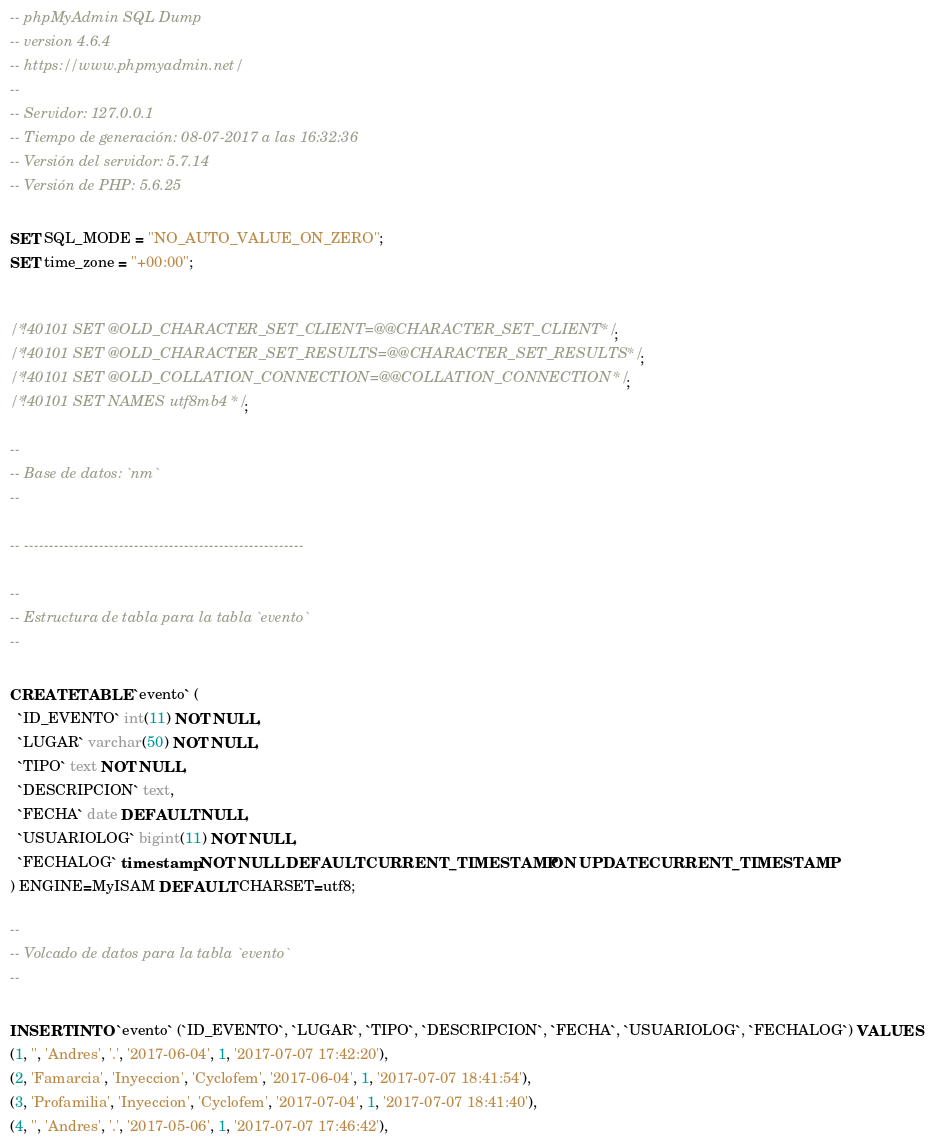<code> <loc_0><loc_0><loc_500><loc_500><_SQL_>-- phpMyAdmin SQL Dump
-- version 4.6.4
-- https://www.phpmyadmin.net/
--
-- Servidor: 127.0.0.1
-- Tiempo de generación: 08-07-2017 a las 16:32:36
-- Versión del servidor: 5.7.14
-- Versión de PHP: 5.6.25

SET SQL_MODE = "NO_AUTO_VALUE_ON_ZERO";
SET time_zone = "+00:00";


/*!40101 SET @OLD_CHARACTER_SET_CLIENT=@@CHARACTER_SET_CLIENT */;
/*!40101 SET @OLD_CHARACTER_SET_RESULTS=@@CHARACTER_SET_RESULTS */;
/*!40101 SET @OLD_COLLATION_CONNECTION=@@COLLATION_CONNECTION */;
/*!40101 SET NAMES utf8mb4 */;

--
-- Base de datos: `nm`
--

-- --------------------------------------------------------

--
-- Estructura de tabla para la tabla `evento`
--

CREATE TABLE `evento` (
  `ID_EVENTO` int(11) NOT NULL,
  `LUGAR` varchar(50) NOT NULL,
  `TIPO` text NOT NULL,
  `DESCRIPCION` text,
  `FECHA` date DEFAULT NULL,
  `USUARIOLOG` bigint(11) NOT NULL,
  `FECHALOG` timestamp NOT NULL DEFAULT CURRENT_TIMESTAMP ON UPDATE CURRENT_TIMESTAMP
) ENGINE=MyISAM DEFAULT CHARSET=utf8;

--
-- Volcado de datos para la tabla `evento`
--

INSERT INTO `evento` (`ID_EVENTO`, `LUGAR`, `TIPO`, `DESCRIPCION`, `FECHA`, `USUARIOLOG`, `FECHALOG`) VALUES
(1, '', 'Andres', '.', '2017-06-04', 1, '2017-07-07 17:42:20'),
(2, 'Famarcia', 'Inyeccion', 'Cyclofem', '2017-06-04', 1, '2017-07-07 18:41:54'),
(3, 'Profamilia', 'Inyeccion', 'Cyclofem', '2017-07-04', 1, '2017-07-07 18:41:40'),
(4, '', 'Andres', '.', '2017-05-06', 1, '2017-07-07 17:46:42'),</code> 